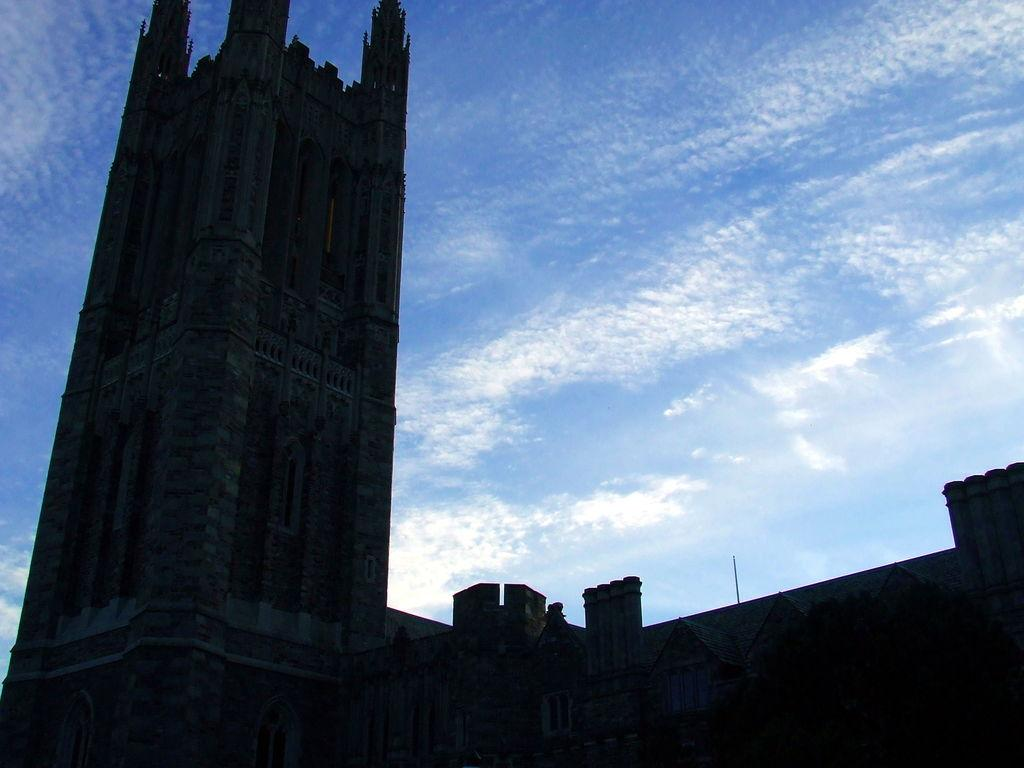What structures are present in the image? There are buildings in the image. What is visible in the background of the image? The sky is visible in the background of the image. What can be seen in the sky in the background of the image? There are clouds in the sky in the background of the image. What type of slave is depicted in the image? There is no depiction of a slave in the image; it features buildings and clouds in the sky. What type of vessel is present in the image? There is no vessel present in the image. 